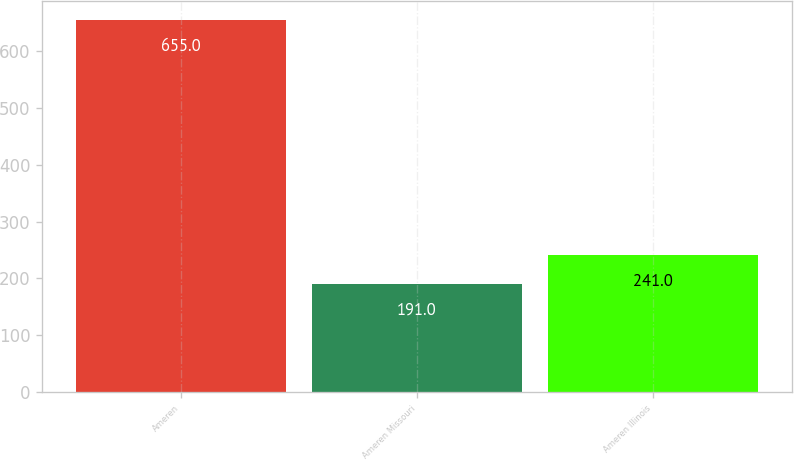Convert chart. <chart><loc_0><loc_0><loc_500><loc_500><bar_chart><fcel>Ameren<fcel>Ameren Missouri<fcel>Ameren Illinois<nl><fcel>655<fcel>191<fcel>241<nl></chart> 